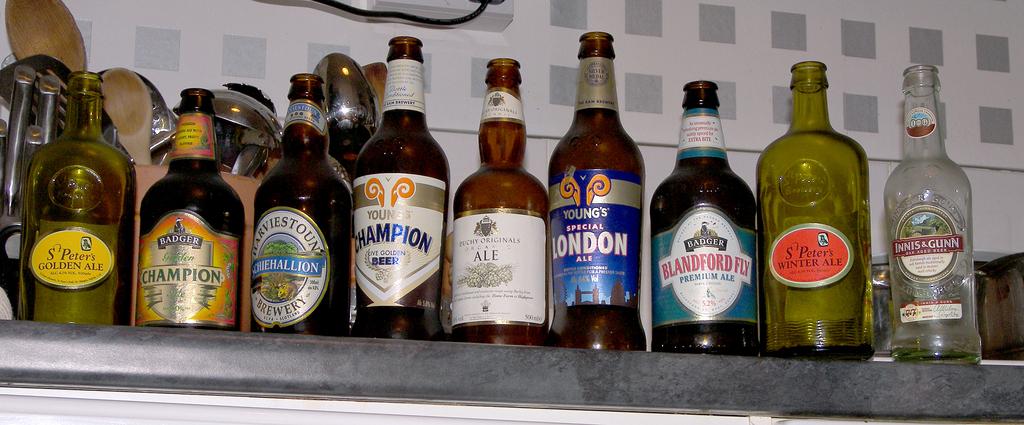What one of the bottles say?
Give a very brief answer. London. What city is young's ale from?
Provide a short and direct response. London. 